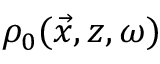<formula> <loc_0><loc_0><loc_500><loc_500>\rho _ { 0 } ( \vec { x } , z , \omega )</formula> 